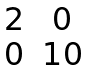<formula> <loc_0><loc_0><loc_500><loc_500>\begin{matrix} 2 & 0 \\ 0 & 1 0 \end{matrix}</formula> 